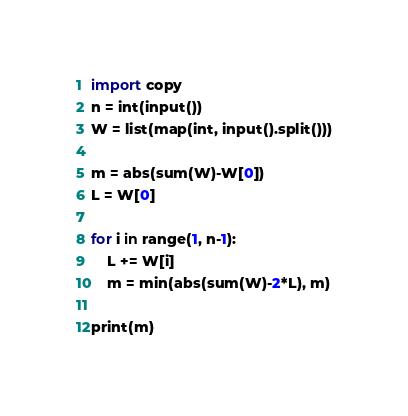<code> <loc_0><loc_0><loc_500><loc_500><_Python_>import copy
n = int(input())
W = list(map(int, input().split()))

m = abs(sum(W)-W[0])
L = W[0]

for i in range(1, n-1):
    L += W[i]
    m = min(abs(sum(W)-2*L), m)
    
print(m)
</code> 